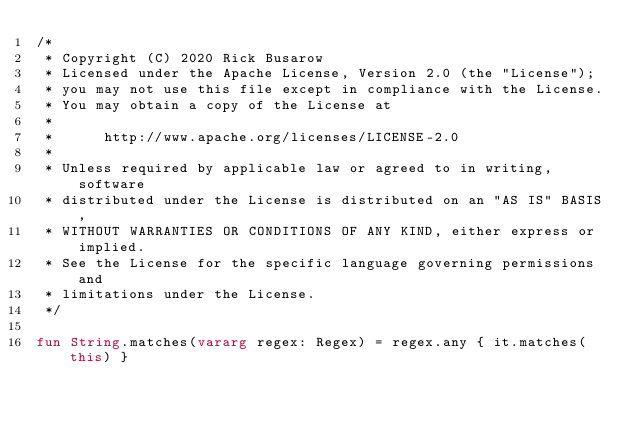Convert code to text. <code><loc_0><loc_0><loc_500><loc_500><_Kotlin_>/*
 * Copyright (C) 2020 Rick Busarow
 * Licensed under the Apache License, Version 2.0 (the "License");
 * you may not use this file except in compliance with the License.
 * You may obtain a copy of the License at
 *
 *      http://www.apache.org/licenses/LICENSE-2.0
 *
 * Unless required by applicable law or agreed to in writing, software
 * distributed under the License is distributed on an "AS IS" BASIS,
 * WITHOUT WARRANTIES OR CONDITIONS OF ANY KIND, either express or implied.
 * See the License for the specific language governing permissions and
 * limitations under the License.
 */

fun String.matches(vararg regex: Regex) = regex.any { it.matches(this) }
</code> 